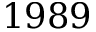<formula> <loc_0><loc_0><loc_500><loc_500>1 9 8 9</formula> 